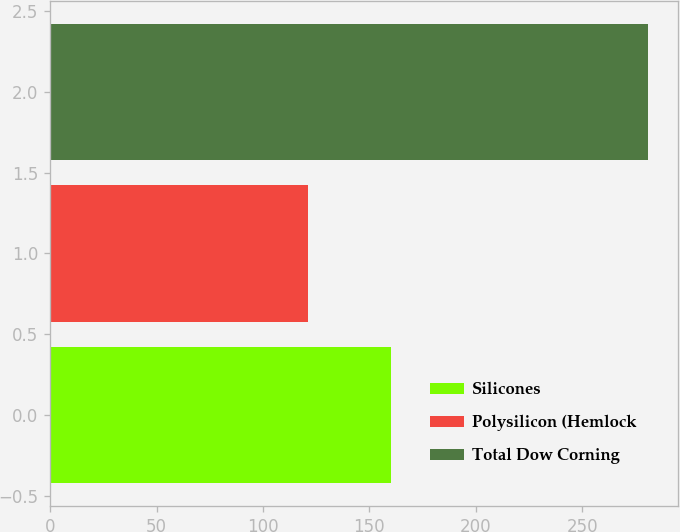Convert chart to OTSL. <chart><loc_0><loc_0><loc_500><loc_500><bar_chart><fcel>Silicones<fcel>Polysilicon (Hemlock<fcel>Total Dow Corning<nl><fcel>160<fcel>121<fcel>281<nl></chart> 